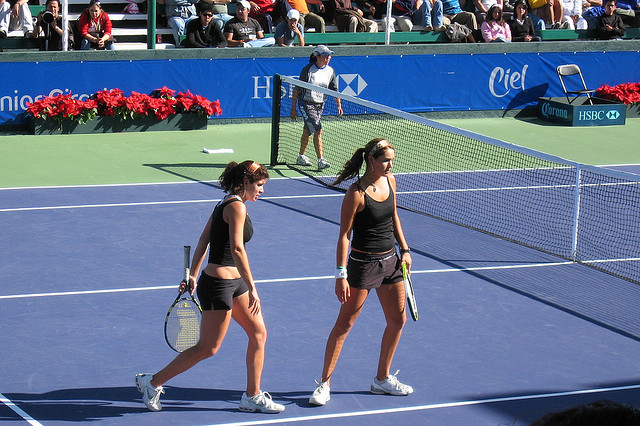Can you tell me about the tournament setting in this image? The image shows a professional tennis court with a blue playing surface, which is commonly used in hard court tournaments. There are sponsor banners around the court, signaling that this is likely part of an organized event. The presence of spectators and line judges also points to a formal competition setting, possibly a part of a larger tennis tournament. What does the environment suggest about the level of the tournament? Given the presence of sponsored banners, line judges, and a visible audience, this likely indicates that the tournament is of a significant level, perhaps a professional or high-tier amateur event. The infrastructure and organization suggest that it's an event with enough resources and interest to attract sponsors and spectators. 